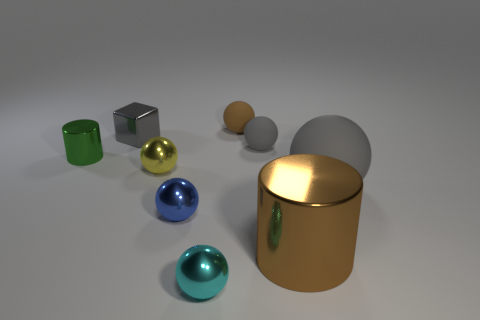Subtract 3 spheres. How many spheres are left? 3 Subtract all large balls. How many balls are left? 5 Subtract all yellow balls. How many balls are left? 5 Subtract all green balls. Subtract all blue cubes. How many balls are left? 6 Add 1 big things. How many objects exist? 10 Subtract all cylinders. How many objects are left? 7 Subtract all big yellow cubes. Subtract all tiny blue shiny things. How many objects are left? 8 Add 2 large brown metallic objects. How many large brown metallic objects are left? 3 Add 4 small brown cylinders. How many small brown cylinders exist? 4 Subtract 0 brown blocks. How many objects are left? 9 